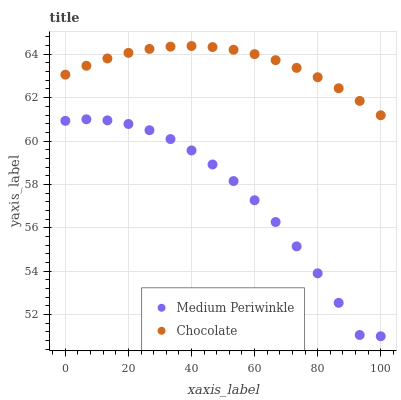Does Medium Periwinkle have the minimum area under the curve?
Answer yes or no. Yes. Does Chocolate have the maximum area under the curve?
Answer yes or no. Yes. Does Chocolate have the minimum area under the curve?
Answer yes or no. No. Is Chocolate the smoothest?
Answer yes or no. Yes. Is Medium Periwinkle the roughest?
Answer yes or no. Yes. Is Chocolate the roughest?
Answer yes or no. No. Does Medium Periwinkle have the lowest value?
Answer yes or no. Yes. Does Chocolate have the lowest value?
Answer yes or no. No. Does Chocolate have the highest value?
Answer yes or no. Yes. Is Medium Periwinkle less than Chocolate?
Answer yes or no. Yes. Is Chocolate greater than Medium Periwinkle?
Answer yes or no. Yes. Does Medium Periwinkle intersect Chocolate?
Answer yes or no. No. 